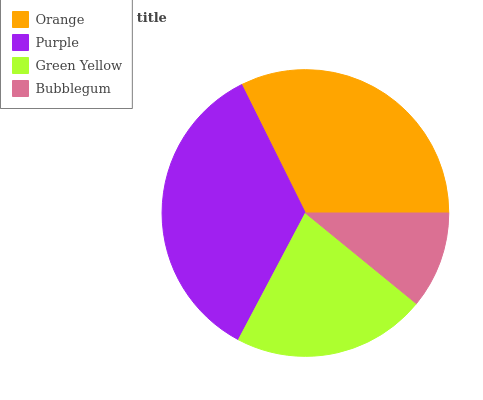Is Bubblegum the minimum?
Answer yes or no. Yes. Is Purple the maximum?
Answer yes or no. Yes. Is Green Yellow the minimum?
Answer yes or no. No. Is Green Yellow the maximum?
Answer yes or no. No. Is Purple greater than Green Yellow?
Answer yes or no. Yes. Is Green Yellow less than Purple?
Answer yes or no. Yes. Is Green Yellow greater than Purple?
Answer yes or no. No. Is Purple less than Green Yellow?
Answer yes or no. No. Is Orange the high median?
Answer yes or no. Yes. Is Green Yellow the low median?
Answer yes or no. Yes. Is Green Yellow the high median?
Answer yes or no. No. Is Bubblegum the low median?
Answer yes or no. No. 